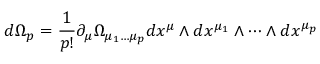Convert formula to latex. <formula><loc_0><loc_0><loc_500><loc_500>d \Omega _ { p } = \frac { 1 } { p ! } \partial _ { \mu } \Omega _ { \mu _ { 1 } \dots \mu _ { p } } d x ^ { \mu } \wedge d x ^ { \mu _ { 1 } } \wedge \dots \wedge d x ^ { \mu _ { p } }</formula> 